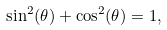<formula> <loc_0><loc_0><loc_500><loc_500>\sin ^ { 2 } ( \theta ) + \cos ^ { 2 } ( \theta ) = 1 ,</formula> 